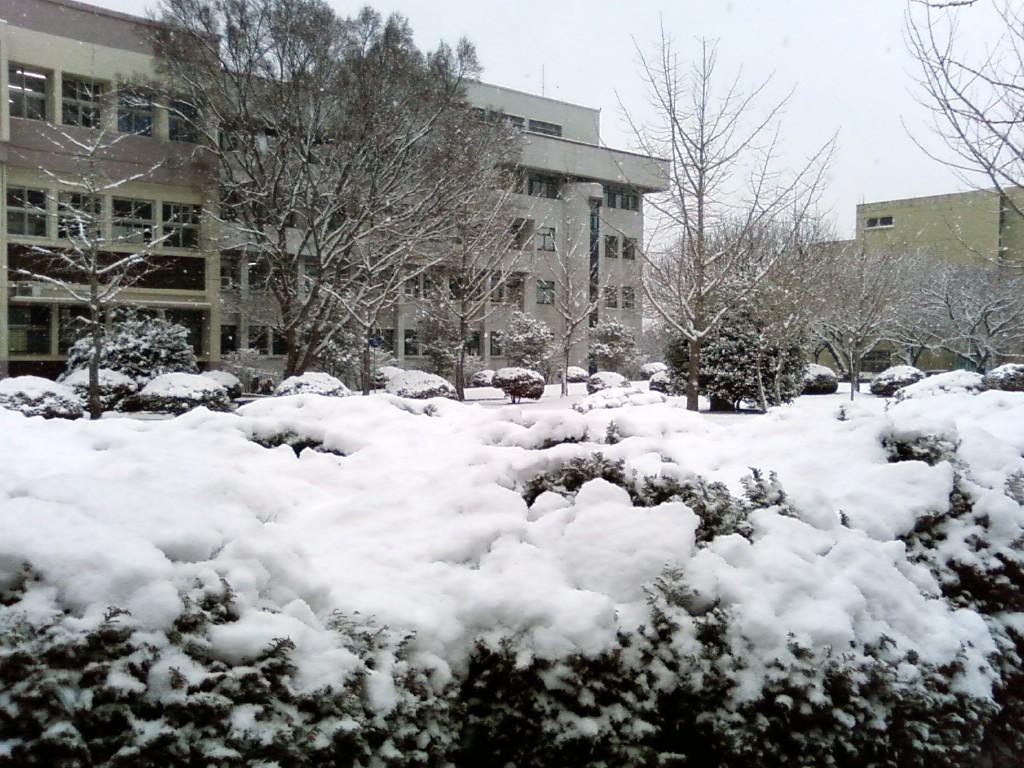In one or two sentences, can you explain what this image depicts? In the center of the image there are buildings and trees. At the bottom there is snow. In the background there is sky. 